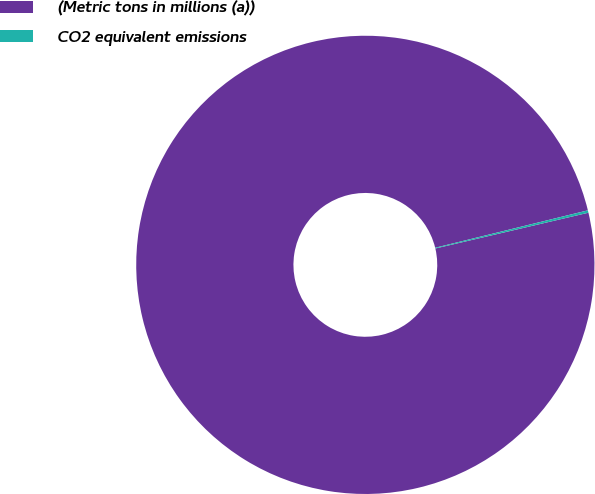<chart> <loc_0><loc_0><loc_500><loc_500><pie_chart><fcel>(Metric tons in millions (a))<fcel>CO2 equivalent emissions<nl><fcel>99.83%<fcel>0.17%<nl></chart> 